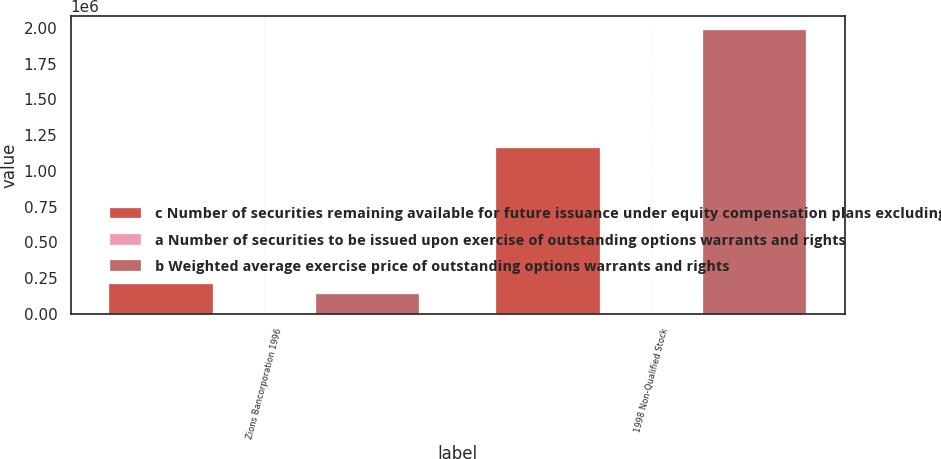<chart> <loc_0><loc_0><loc_500><loc_500><stacked_bar_chart><ecel><fcel>Zions Bancorporation 1996<fcel>1998 Non-Qualified Stock<nl><fcel>c Number of securities remaining available for future issuance under equity compensation plans excluding securities reflected in column a<fcel>207689<fcel>1.15701e+06<nl><fcel>a Number of securities to be issued upon exercise of outstanding options warrants and rights<fcel>49.71<fcel>49.88<nl><fcel>b Weighted average exercise price of outstanding options warrants and rights<fcel>141000<fcel>1.98347e+06<nl></chart> 